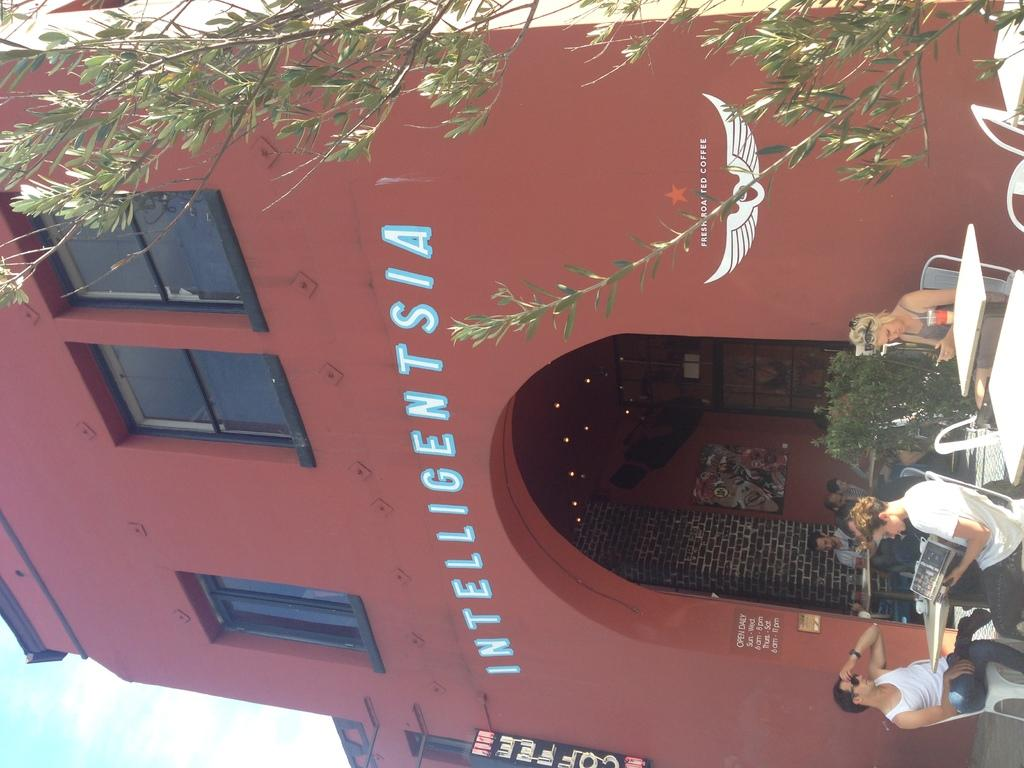What is the color of the building in the image? The building in the image is red. What are the people in the image doing? The groups of persons are sitting on chairs around tables. What can be seen on the right side of the image? There is a tree on the right side of the image. Is there a judge presiding over a trial in the image? No, there is no judge or trial depicted in the image. What type of volcano can be seen erupting in the background of the image? There is no volcano present in the image; it features a red building, groups of people sitting on chairs around tables, and a tree on the right side. 